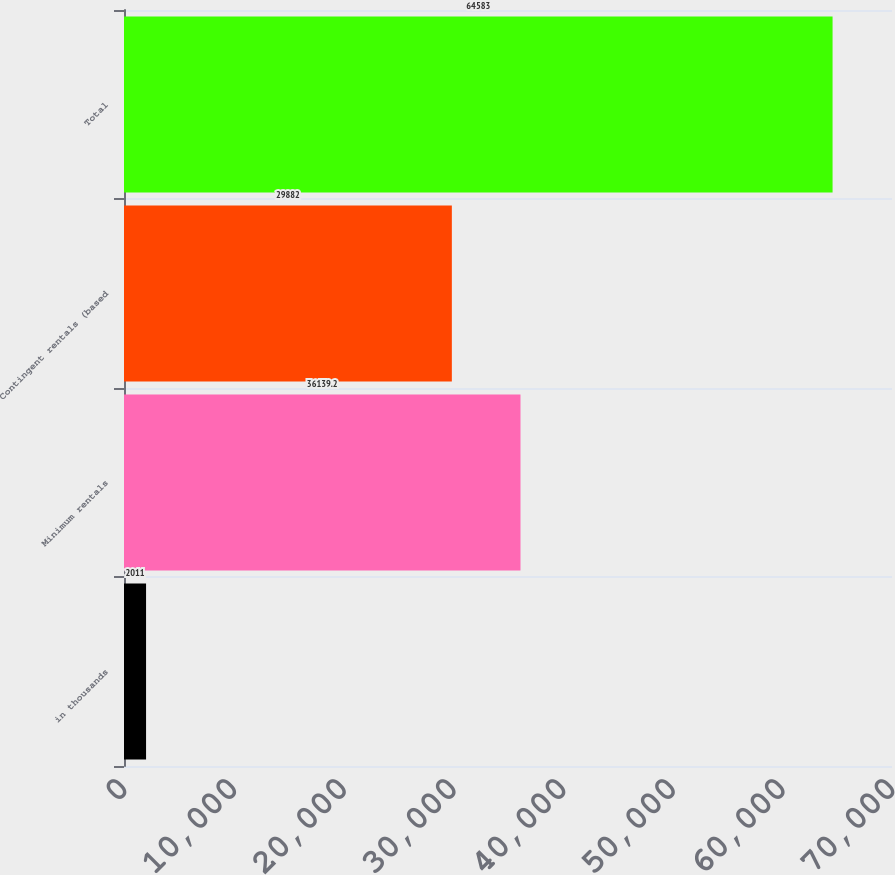<chart> <loc_0><loc_0><loc_500><loc_500><bar_chart><fcel>in thousands<fcel>Minimum rentals<fcel>Contingent rentals (based<fcel>Total<nl><fcel>2011<fcel>36139.2<fcel>29882<fcel>64583<nl></chart> 